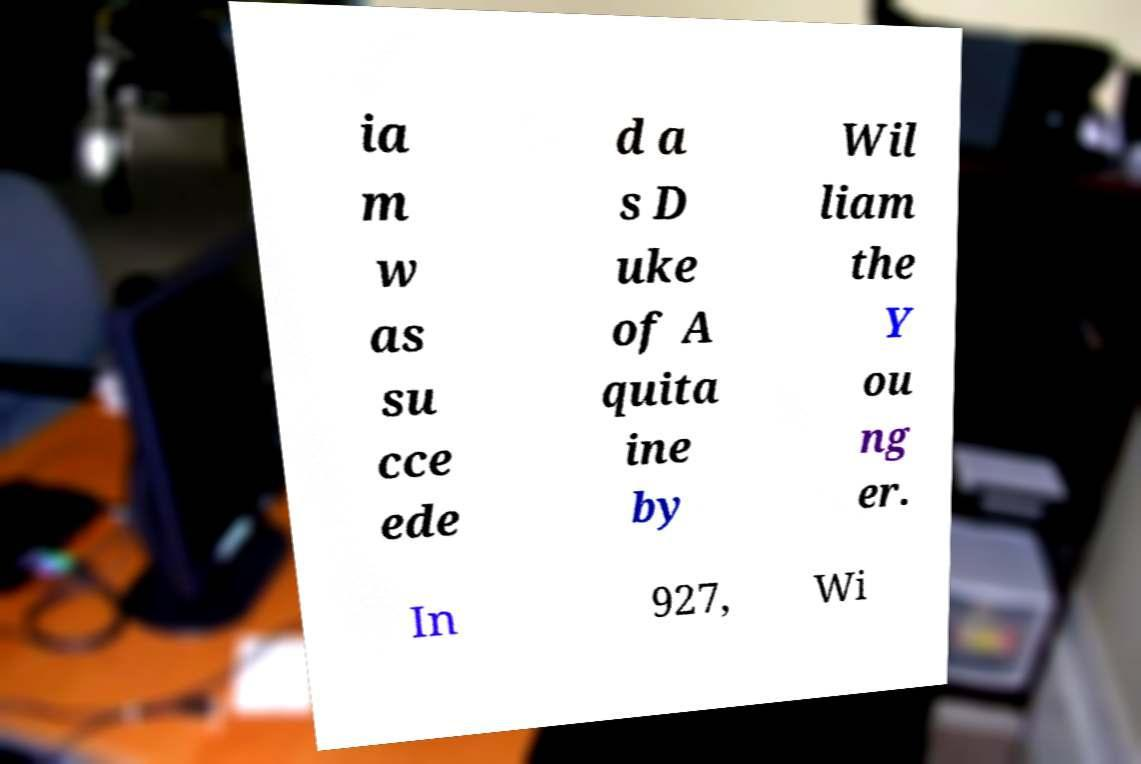Please read and relay the text visible in this image. What does it say? ia m w as su cce ede d a s D uke of A quita ine by Wil liam the Y ou ng er. In 927, Wi 